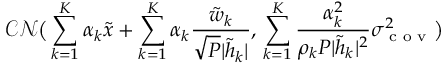Convert formula to latex. <formula><loc_0><loc_0><loc_500><loc_500>\mathcal { C N } \left ( \sum _ { k = 1 } ^ { K } \alpha _ { k } { { \tilde { x } } } + \sum _ { k = 1 } ^ { K } \alpha _ { k } \frac { { { \tilde { w } _ { k } } } } { \sqrt { P } | \tilde { h } _ { k } | } , \, \sum _ { k = 1 } ^ { K } \frac { \alpha _ { k } ^ { 2 } } { \rho _ { k } P | \tilde { h } _ { k } | ^ { 2 } } \sigma _ { c o v } ^ { 2 } \right )</formula> 